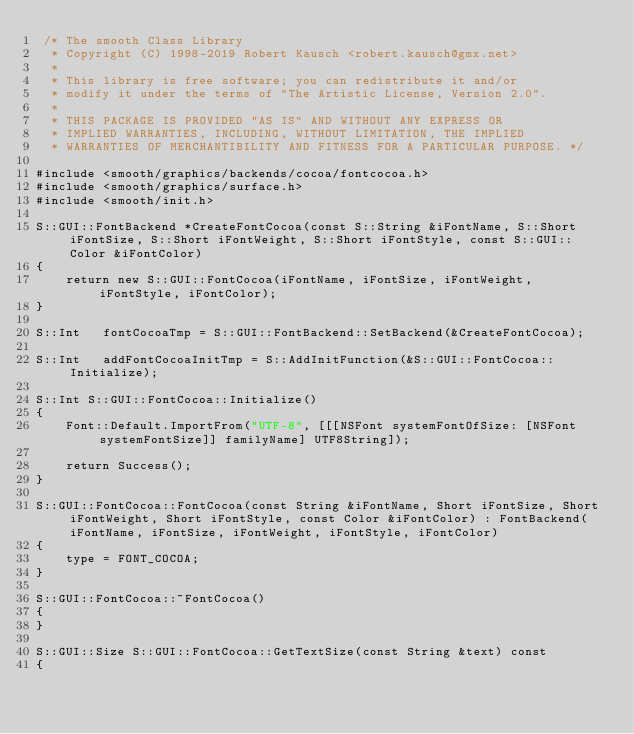Convert code to text. <code><loc_0><loc_0><loc_500><loc_500><_ObjectiveC_> /* The smooth Class Library
  * Copyright (C) 1998-2019 Robert Kausch <robert.kausch@gmx.net>
  *
  * This library is free software; you can redistribute it and/or
  * modify it under the terms of "The Artistic License, Version 2.0".
  *
  * THIS PACKAGE IS PROVIDED "AS IS" AND WITHOUT ANY EXPRESS OR
  * IMPLIED WARRANTIES, INCLUDING, WITHOUT LIMITATION, THE IMPLIED
  * WARRANTIES OF MERCHANTIBILITY AND FITNESS FOR A PARTICULAR PURPOSE. */

#include <smooth/graphics/backends/cocoa/fontcocoa.h>
#include <smooth/graphics/surface.h>
#include <smooth/init.h>

S::GUI::FontBackend *CreateFontCocoa(const S::String &iFontName, S::Short iFontSize, S::Short iFontWeight, S::Short iFontStyle, const S::GUI::Color &iFontColor)
{
	return new S::GUI::FontCocoa(iFontName, iFontSize, iFontWeight, iFontStyle, iFontColor);
}

S::Int	 fontCocoaTmp = S::GUI::FontBackend::SetBackend(&CreateFontCocoa);

S::Int	 addFontCocoaInitTmp = S::AddInitFunction(&S::GUI::FontCocoa::Initialize);

S::Int S::GUI::FontCocoa::Initialize()
{
	Font::Default.ImportFrom("UTF-8", [[[NSFont systemFontOfSize: [NSFont systemFontSize]] familyName] UTF8String]);

	return Success();
}

S::GUI::FontCocoa::FontCocoa(const String &iFontName, Short iFontSize, Short iFontWeight, Short iFontStyle, const Color &iFontColor) : FontBackend(iFontName, iFontSize, iFontWeight, iFontStyle, iFontColor)
{
	type = FONT_COCOA;
}

S::GUI::FontCocoa::~FontCocoa()
{
}

S::GUI::Size S::GUI::FontCocoa::GetTextSize(const String &text) const
{</code> 